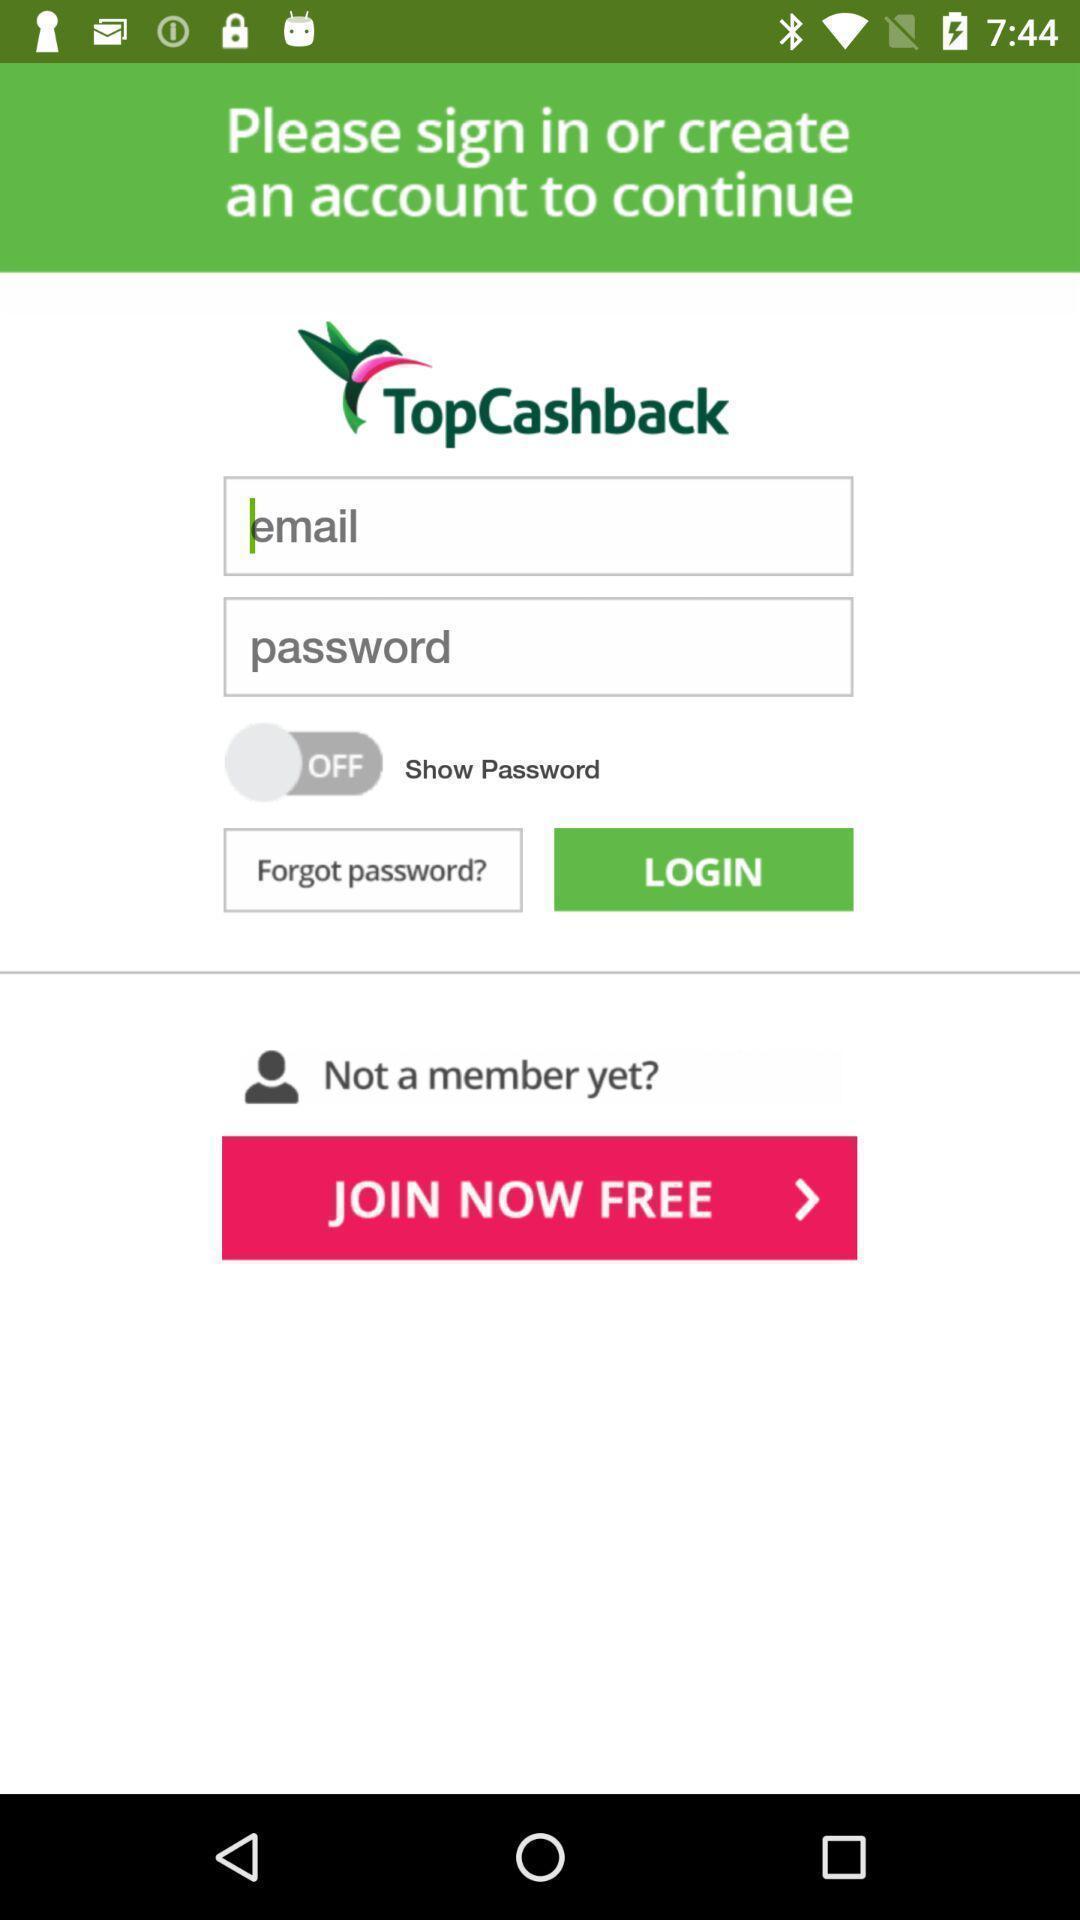Tell me what you see in this picture. Startup page of the application to get the access. 